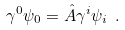Convert formula to latex. <formula><loc_0><loc_0><loc_500><loc_500>\gamma ^ { 0 } \psi _ { 0 } = \hat { A } \gamma ^ { i } \psi _ { i } \ .</formula> 